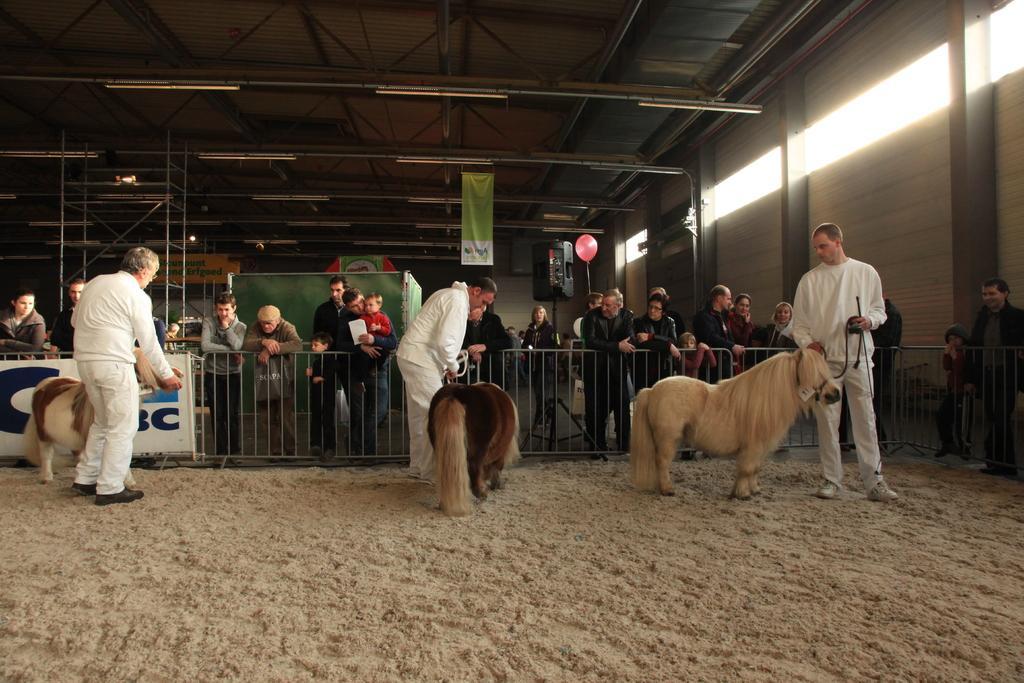Can you describe this image briefly? In this image few animals are on the land. Three persons wearing white dress are holding belts tied to animals. Few persons are standing behind the fence. A person is holding baby in his arms. There is a sound speaker attached to the stand. Beside there is a balloon. Few banners are hanged from the roof having few lights attached to the rods. 